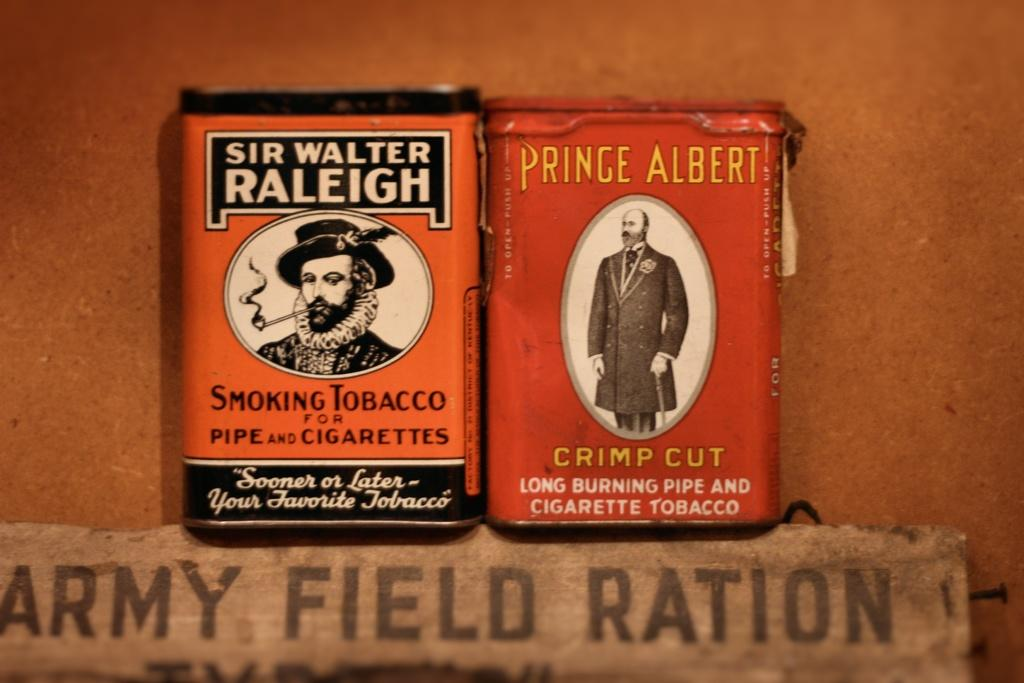<image>
Relay a brief, clear account of the picture shown. Two cans of smoking tobacco from Sir Walter Raliegh and Prince Albert brands. 